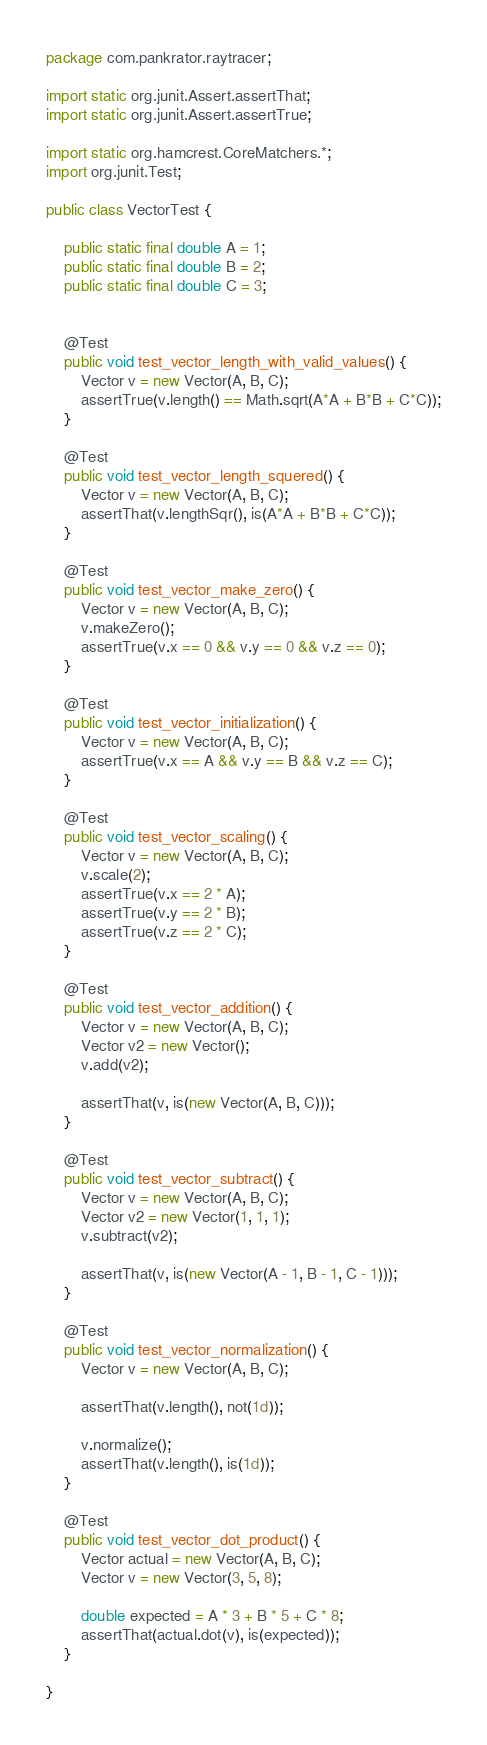Convert code to text. <code><loc_0><loc_0><loc_500><loc_500><_Java_>package com.pankrator.raytracer;

import static org.junit.Assert.assertThat;
import static org.junit.Assert.assertTrue;

import static org.hamcrest.CoreMatchers.*;
import org.junit.Test;

public class VectorTest {
	
	public static final double A = 1;
	public static final double B = 2;
	public static final double C = 3;
	
	
	@Test
	public void test_vector_length_with_valid_values() {
		Vector v = new Vector(A, B, C);
		assertTrue(v.length() == Math.sqrt(A*A + B*B + C*C));
	}
	
	@Test
	public void test_vector_length_squered() {
		Vector v = new Vector(A, B, C);
		assertThat(v.lengthSqr(), is(A*A + B*B + C*C));
	}
	
	@Test
	public void test_vector_make_zero() {
		Vector v = new Vector(A, B, C);
		v.makeZero();
		assertTrue(v.x == 0 && v.y == 0 && v.z == 0);
	}
	
	@Test
	public void test_vector_initialization() {
		Vector v = new Vector(A, B, C);
		assertTrue(v.x == A && v.y == B && v.z == C);
	}
	
	@Test
	public void test_vector_scaling() {
		Vector v = new Vector(A, B, C);
		v.scale(2);
		assertTrue(v.x == 2 * A);
		assertTrue(v.y == 2 * B);
		assertTrue(v.z == 2 * C);
	}
	
	@Test
	public void test_vector_addition() {
		Vector v = new Vector(A, B, C);
		Vector v2 = new Vector();
		v.add(v2);
		
		assertThat(v, is(new Vector(A, B, C)));
	}
	
	@Test
	public void test_vector_subtract() {
		Vector v = new Vector(A, B, C);
		Vector v2 = new Vector(1, 1, 1);
		v.subtract(v2);
		
		assertThat(v, is(new Vector(A - 1, B - 1, C - 1)));
	}
	
	@Test
	public void test_vector_normalization() {
		Vector v = new Vector(A, B, C);
		
		assertThat(v.length(), not(1d));
		
		v.normalize();
		assertThat(v.length(), is(1d));
	}
	
	@Test
	public void test_vector_dot_product() {
		Vector actual = new Vector(A, B, C);
		Vector v = new Vector(3, 5, 8);
		
		double expected = A * 3 + B * 5 + C * 8;
		assertThat(actual.dot(v), is(expected));
	}	
	
}
</code> 